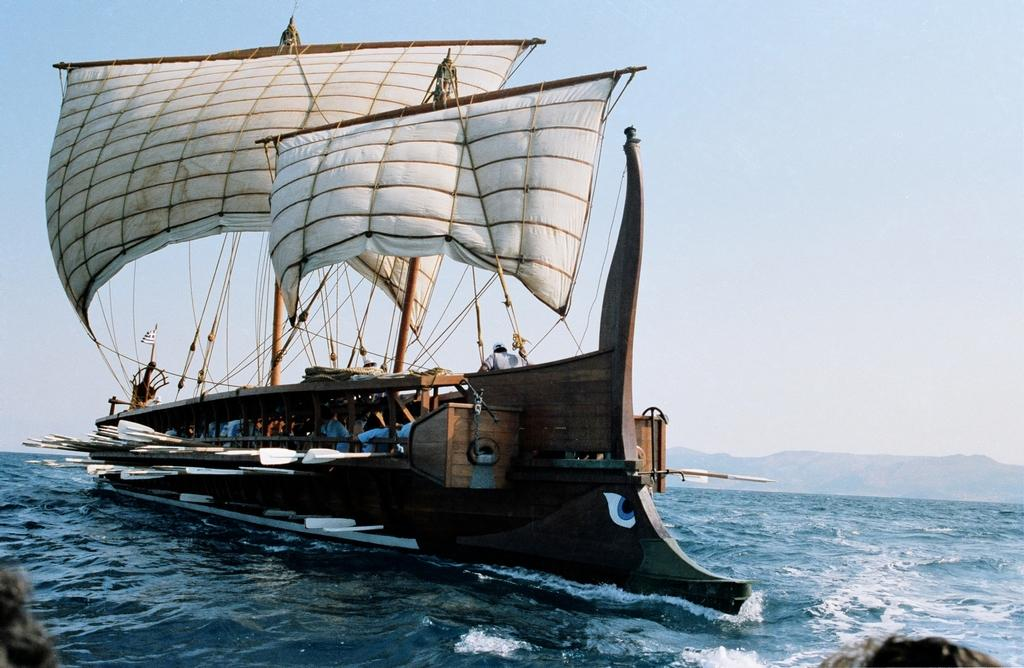What type of ship is in the image? There is an ancient Greek trireme in the image. Where is the trireme located? The trireme is on water. What can be seen in the background of the image? There is a mountain and a clear sky in the background of the image. What brand of toothpaste is being used by the birds in the image? There are no birds present in the image, and therefore no toothpaste can be associated with them. 